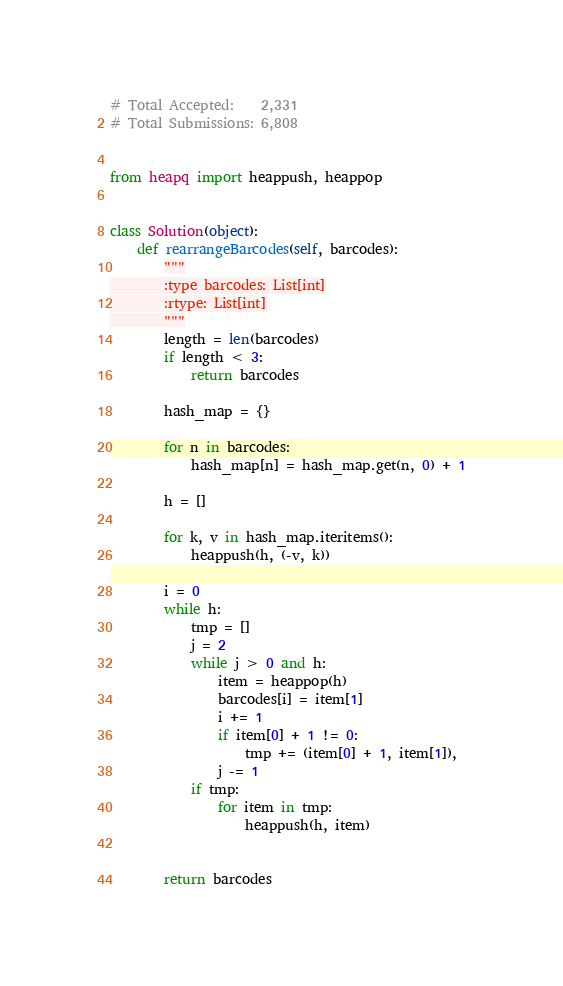Convert code to text. <code><loc_0><loc_0><loc_500><loc_500><_Python_># Total Accepted:    2,331
# Total Submissions: 6,808


from heapq import heappush, heappop


class Solution(object):
    def rearrangeBarcodes(self, barcodes):
        """
        :type barcodes: List[int]
        :rtype: List[int]
        """
        length = len(barcodes)
        if length < 3:
            return barcodes

        hash_map = {}

        for n in barcodes:
            hash_map[n] = hash_map.get(n, 0) + 1

        h = []

        for k, v in hash_map.iteritems():
            heappush(h, (-v, k))

        i = 0
        while h:
            tmp = []
            j = 2
            while j > 0 and h:
                item = heappop(h)
                barcodes[i] = item[1]
                i += 1
                if item[0] + 1 != 0:
                    tmp += (item[0] + 1, item[1]),
                j -= 1
            if tmp:
                for item in tmp:
                    heappush(h, item)
            

        return barcodes</code> 